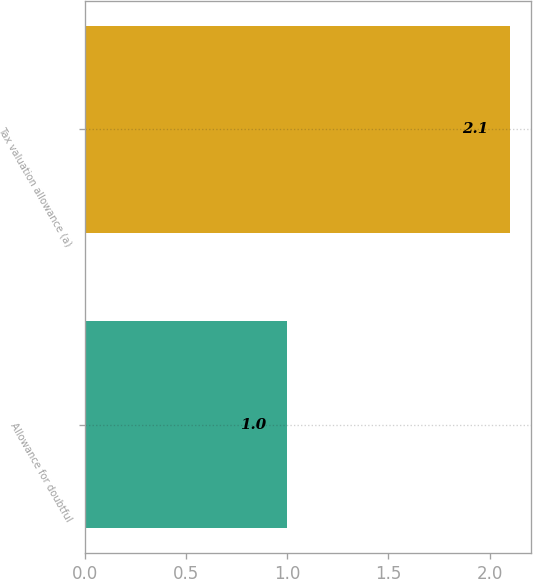Convert chart to OTSL. <chart><loc_0><loc_0><loc_500><loc_500><bar_chart><fcel>Allowance for doubtful<fcel>Tax valuation allowance (a)<nl><fcel>1<fcel>2.1<nl></chart> 